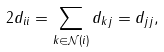Convert formula to latex. <formula><loc_0><loc_0><loc_500><loc_500>2 d _ { i i } = \sum _ { k \in \mathcal { N } ( i ) } d _ { k j } = d _ { j j } ,</formula> 